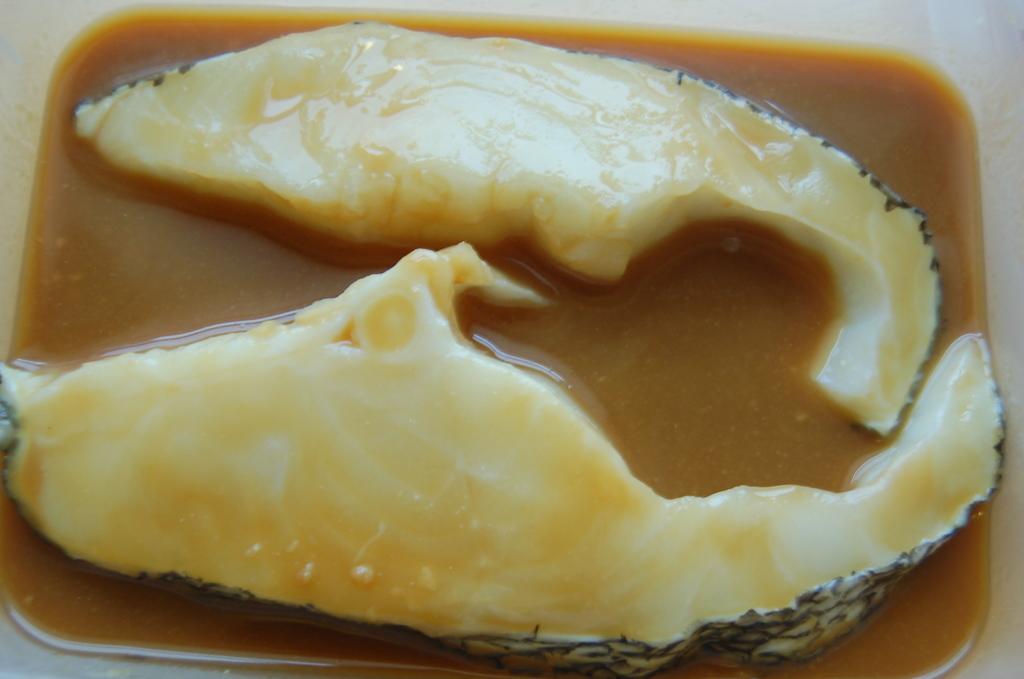How would you summarize this image in a sentence or two? In this image I can see I can see a white colored bowel and on the bowl I can see a soup which is brown in color and two fish pieces which are cream in color. 